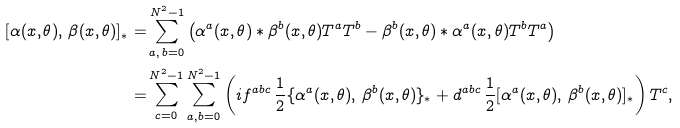Convert formula to latex. <formula><loc_0><loc_0><loc_500><loc_500>[ \alpha ( x , \theta ) , \, \beta ( x , \theta ) ] _ { \ast } = & \sum _ { a , \, b = 0 } ^ { N ^ { 2 } - 1 } \left ( \alpha ^ { a } ( x , \theta ) \ast \beta ^ { b } ( x , \theta ) T ^ { a } T ^ { b } - \beta ^ { b } ( x , \theta ) \ast \alpha ^ { a } ( x , \theta ) T ^ { b } T ^ { a } \right ) \\ = & \sum _ { c = 0 } ^ { N ^ { 2 } - 1 } \sum _ { a , b = 0 } ^ { N ^ { 2 } - 1 } \left ( i f ^ { a b c } \, \frac { 1 } { 2 } \{ \alpha ^ { a } ( x , \theta ) , \, \beta ^ { b } ( x , \theta ) \} _ { \ast } + d ^ { a b c } \, \frac { 1 } { 2 } [ \alpha ^ { a } ( x , \theta ) , \, \beta ^ { b } ( x , \theta ) ] _ { \ast } \right ) T ^ { c } ,</formula> 